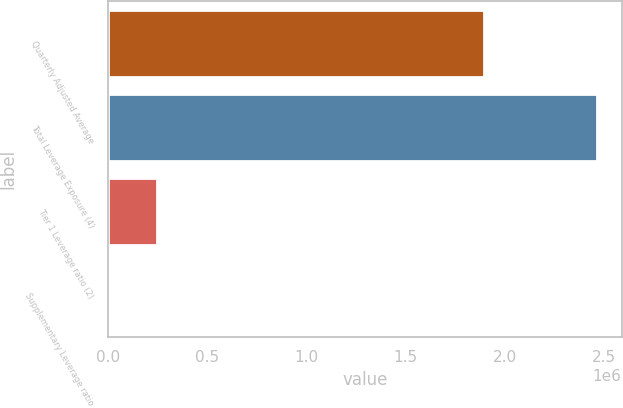Convert chart. <chart><loc_0><loc_0><loc_500><loc_500><bar_chart><fcel>Quarterly Adjusted Average<fcel>Total Leverage Exposure (4)<fcel>Tier 1 Leverage ratio (2)<fcel>Supplementary Leverage ratio<nl><fcel>1.89696e+06<fcel>2.46564e+06<fcel>246570<fcel>6.41<nl></chart> 